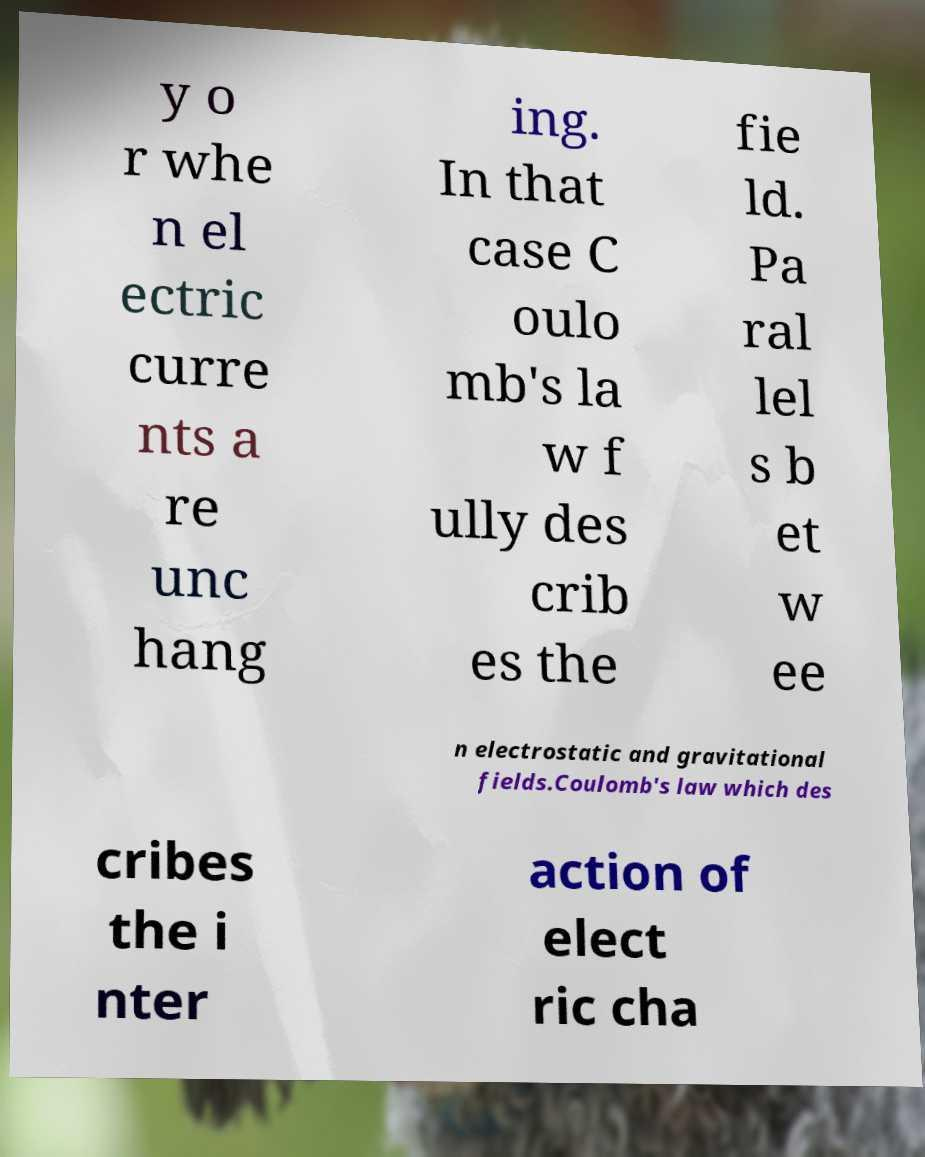For documentation purposes, I need the text within this image transcribed. Could you provide that? y o r whe n el ectric curre nts a re unc hang ing. In that case C oulo mb's la w f ully des crib es the fie ld. Pa ral lel s b et w ee n electrostatic and gravitational fields.Coulomb's law which des cribes the i nter action of elect ric cha 